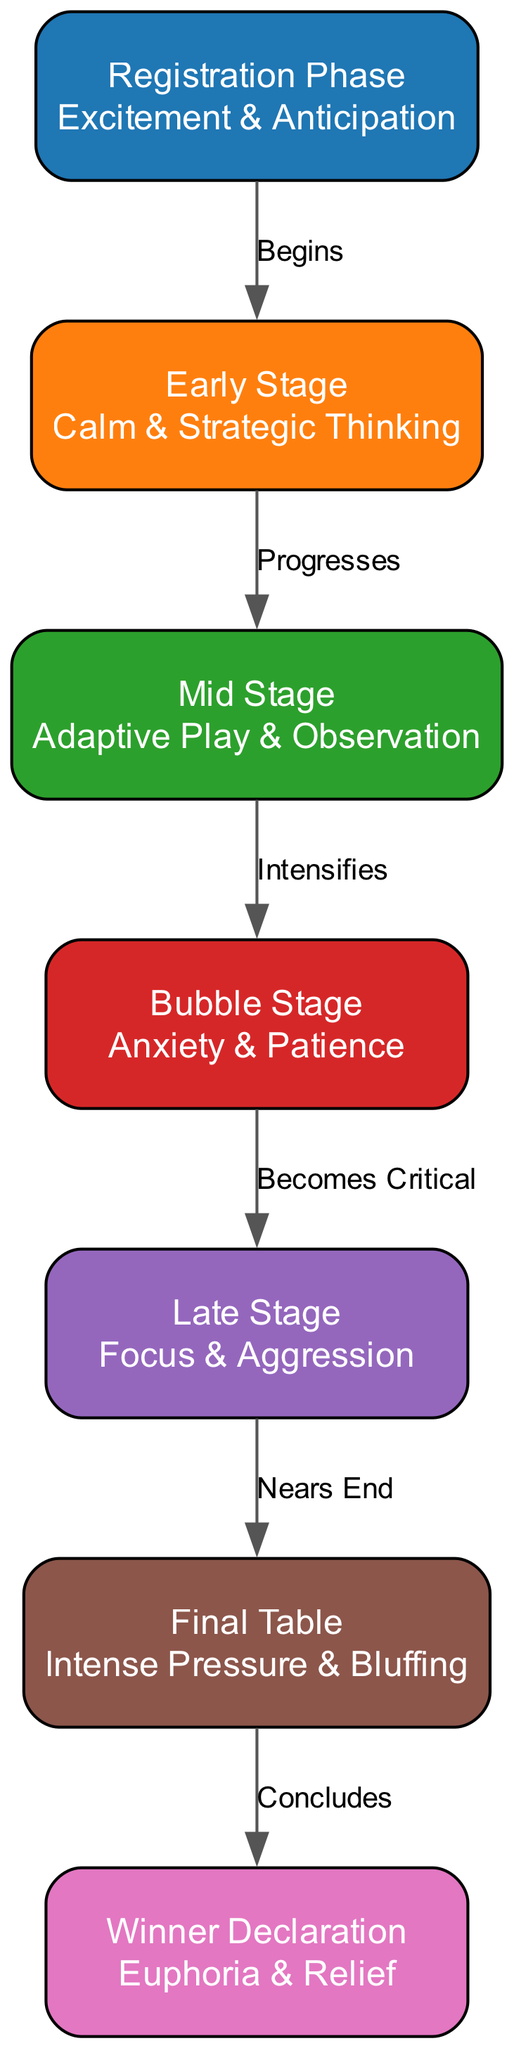What are the key phases of a poker tournament depicted in the diagram? The diagram lists seven phases: Registration Phase, Early Stage, Mid Stage, Bubble Stage, Late Stage, Final Table, and Winner Declaration. These can be identified as distinct nodes within the diagram.
Answer: Registration Phase, Early Stage, Mid Stage, Bubble Stage, Late Stage, Final Table, Winner Declaration How many edges are in the diagram? The diagram includes connections (edges) between the phases, which can be counted directly. There are six edges connecting the seven nodes.
Answer: 6 What psychological state is associated with the Final Table? According to the description provided in the node for the Final Table, the psychological state is "Intense Pressure & Bluffing." This phrasing can be read directly from the node's details within the diagram.
Answer: Intense Pressure & Bluffing Which phase does the Bubble Stage lead to? The diagram illustrates that the Bubble Stage progresses to the Late Stage, as indicated by the connecting edge and its label. By following the path from the Bubble Stage node, it's clear that Late Stage is the next phase.
Answer: Late Stage What is the emotional state during the Registration Phase? From the node labeled "Registration Phase," the emotional state is described as "Excitement & Anticipation." This information is clearly stated within the node's details.
Answer: Excitement & Anticipation How does the Mid Stage transition to the Bubble Stage? The transition is labeled "Intensifies" between the Mid Stage and Bubble Stage nodes. This indicates that the play and strategy grow more intense as players move from Mid Stage to the Bubble Stage.
Answer: Intensifies What is the relationship between the Late Stage and Final Table? The diagram states that the Late Stage "Nears End," indicating that this phase leads directly into the Final Table phase. Therefore, the relationship encompasses a sense of conclusions and moving toward the final moments of the tournament.
Answer: Nears End Which psychological state is experienced in the Winner Declaration phase? The node for Winner Declaration describes the psychological state as "Euphoria & Relief." This provides insight into the emotions felt at the conclusion of the tournament, as noted in the diagram.
Answer: Euphoria & Relief 